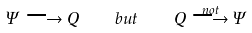Convert formula to latex. <formula><loc_0><loc_0><loc_500><loc_500>\Psi \longrightarrow Q \quad b u t \quad Q \stackrel { n o t } \longrightarrow \Psi</formula> 